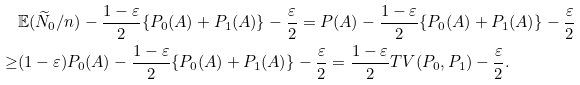<formula> <loc_0><loc_0><loc_500><loc_500>& \mathbb { E } ( \widetilde { N } _ { 0 } / n ) - \frac { 1 - \varepsilon } { 2 } \{ P _ { 0 } ( A ) + P _ { 1 } ( A ) \} - \frac { \varepsilon } { 2 } = P ( A ) - \frac { 1 - \varepsilon } { 2 } \{ P _ { 0 } ( A ) + P _ { 1 } ( A ) \} - \frac { \varepsilon } { 2 } \\ \geq & ( 1 - \varepsilon ) P _ { 0 } ( A ) - \frac { 1 - \varepsilon } { 2 } \{ P _ { 0 } ( A ) + P _ { 1 } ( A ) \} - \frac { \varepsilon } { 2 } = \frac { 1 - \varepsilon } { 2 } T V ( P _ { 0 } , P _ { 1 } ) - \frac { \varepsilon } { 2 } .</formula> 